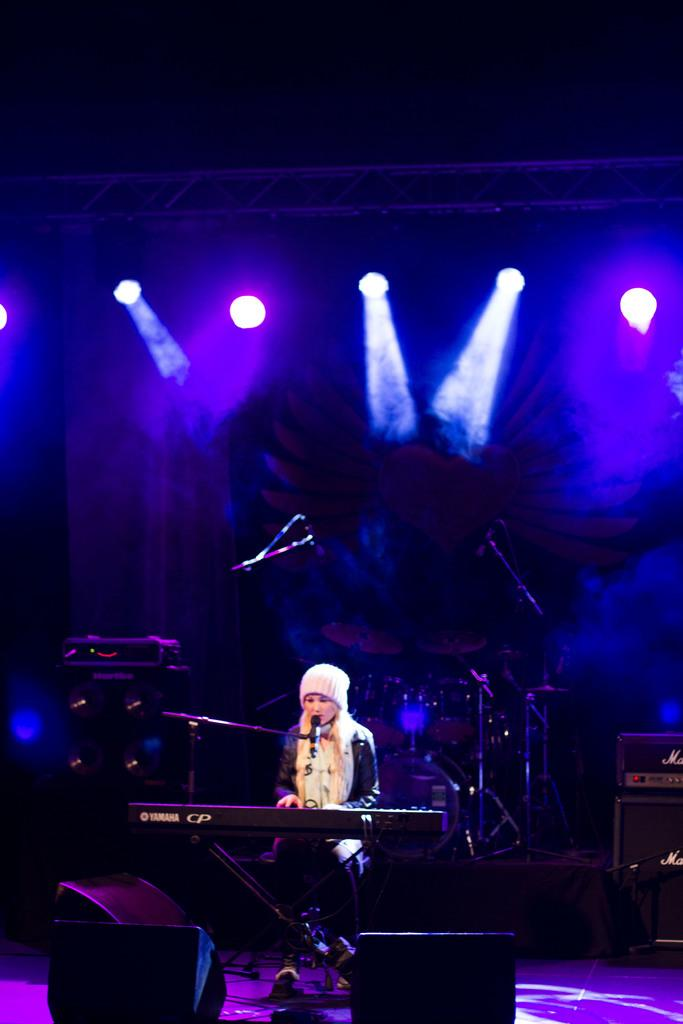Who is the main subject in the image? There is a girl in the image. What is the girl doing in the image? The girl is playing a piano. What other musical instruments can be seen in the image? There are different music instruments around the girl. What can be seen in the background of the image? There are different lights in the background of the image. What type of guitar is the governor playing in the image? There is no guitar or governor present in the image. The main subject is a girl playing a piano, and there are no political figures or additional musical instruments mentioned in the provided facts. 